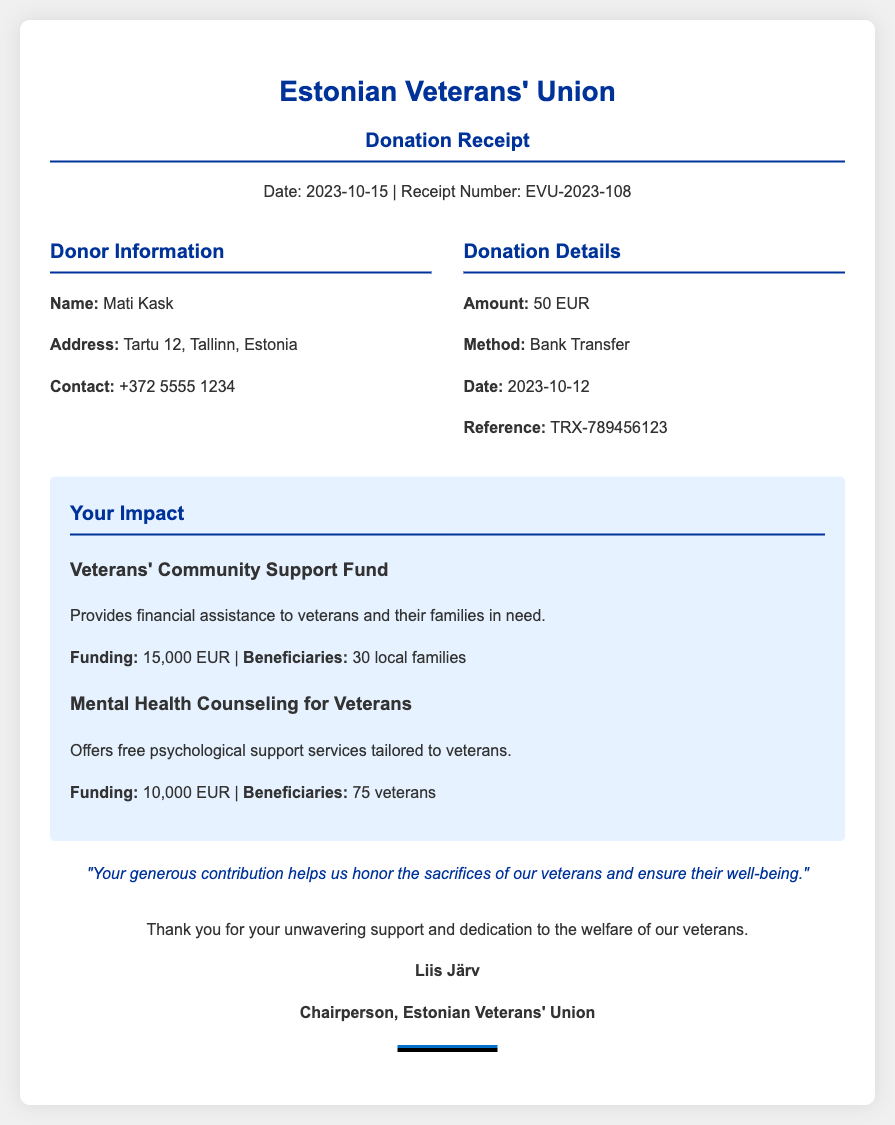What is the name of the donor? The name of the donor is provided in the donor information section of the document.
Answer: Mati Kask What is the donation amount? The donation amount is specified in the donation details of the receipt.
Answer: 50 EUR What is the receipt date? The date of the receipt is listed at the top of the document under the header section.
Answer: 2023-10-15 How much funding is provided for the Mental Health Counseling for Veterans? The funding for this program is detailed in the impact statement section of the document.
Answer: 10,000 EUR How many local families benefited from the Veterans' Community Support Fund? This information is found in the description of the program in the impact statement.
Answer: 30 local families What is the payment method used for the donation? The method of donation is mentioned in the donation details segment of the receipt.
Answer: Bank Transfer Who is the Chairperson of the Estonian Veterans' Union? The chairperson's name is found in the closing statement of the document.
Answer: Liis Järv When was the donation made? The donation date is explicitly stated in the donation details section of the receipt.
Answer: 2023-10-12 What is the reference number for the donation transaction? The reference for the transaction can be located under the donation details section.
Answer: TRX-789456123 